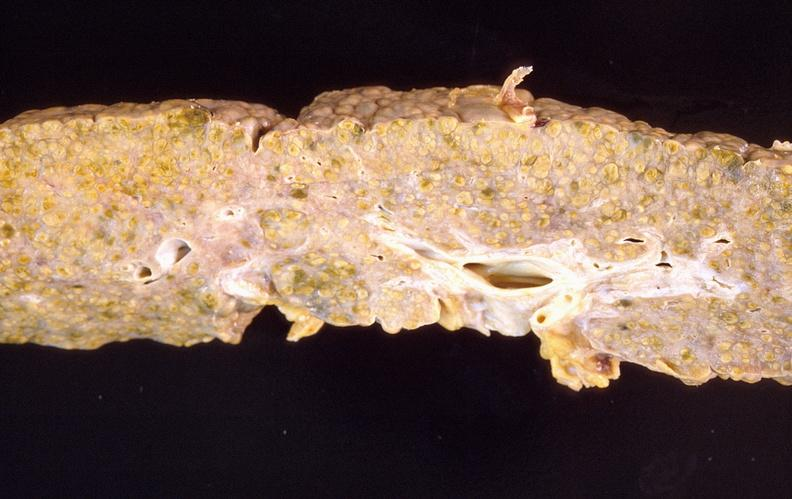does this image show liver cirrhosis?
Answer the question using a single word or phrase. Yes 